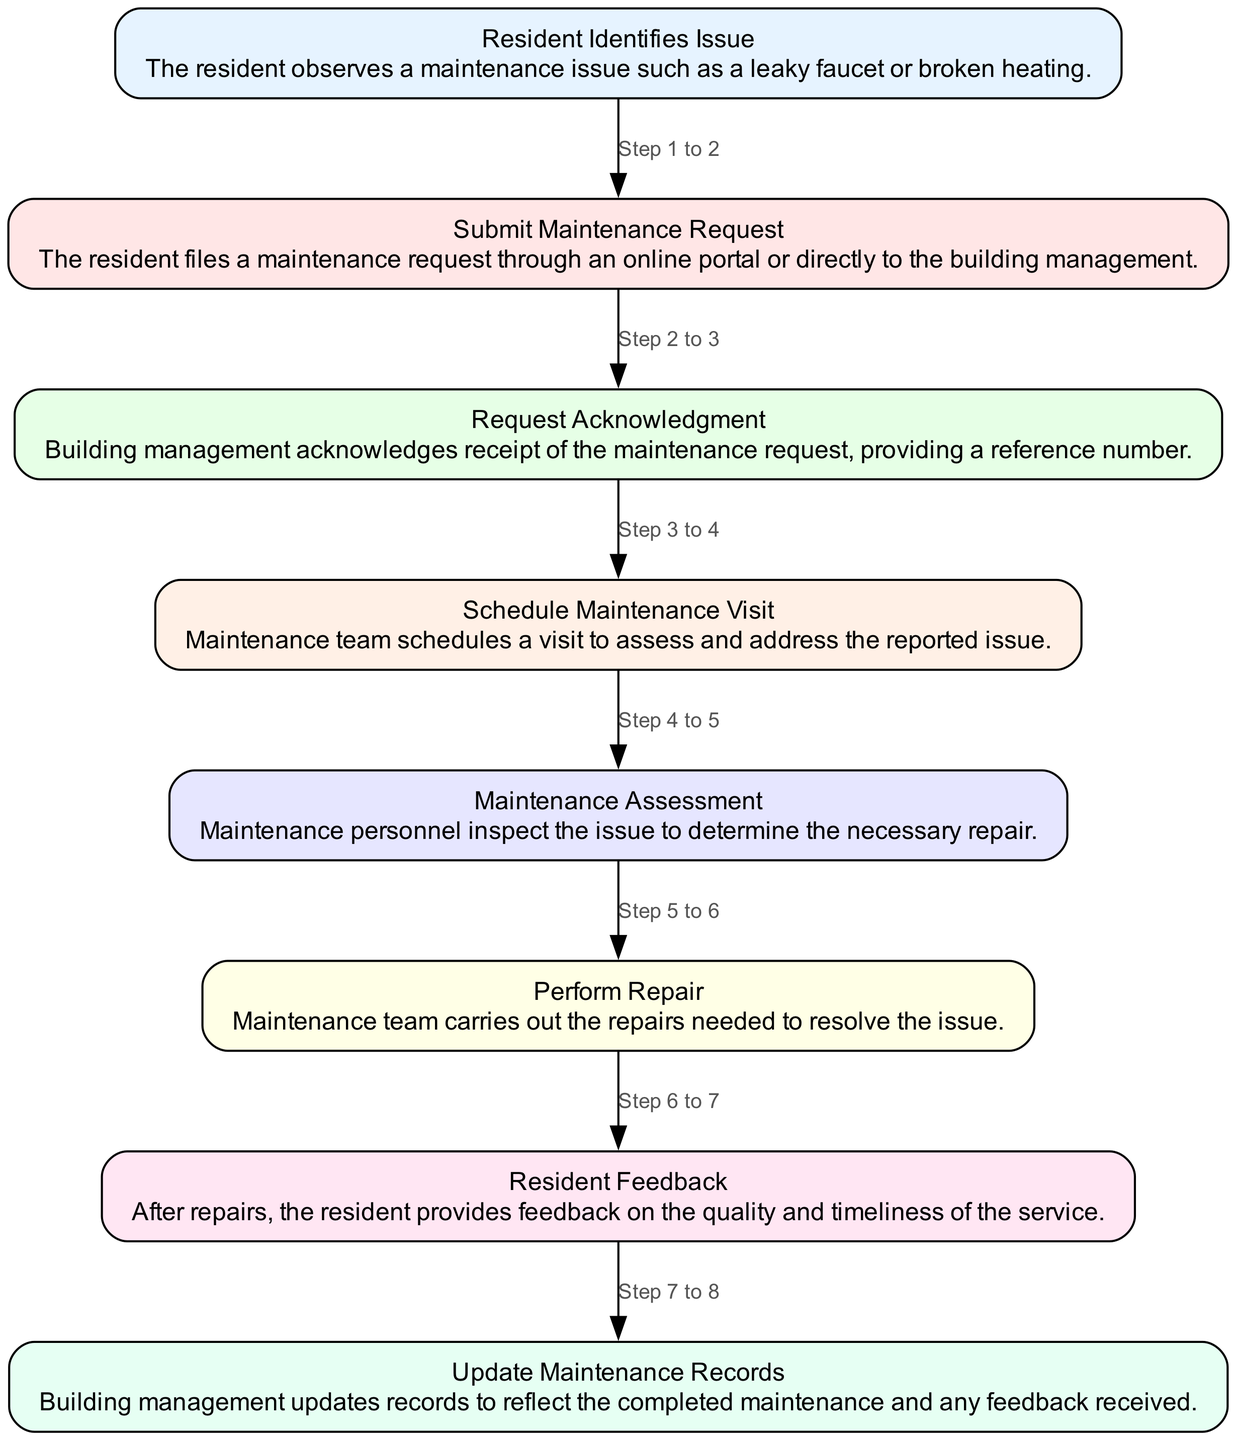What is the first step in the maintenance request process? The first step in the diagram starts with the "Resident Identifies Issue" node, indicating that the resident must recognize a maintenance problem before any action is taken.
Answer: Resident Identifies Issue How many total nodes are there in the flow chart? The flow chart contains eight nodes, each graphically represented by a distinct box marking a particular part of the maintenance process from identifying an issue to updating maintenance records.
Answer: 8 Which step follows "Request Acknowledgment"? After "Request Acknowledgment" (Step 3), the next logical step in the flow is "Schedule Maintenance Visit" (Step 4), making it a direct continuation of the process.
Answer: Schedule Maintenance Visit What action occurs after the "Perform Repair" step? Post the "Perform Repair" step (Step 6), the resident is expected to provide feedback about the maintenance experience in the "Resident Feedback" step (Step 7), ensuring resident involvement and satisfaction assessment.
Answer: Resident Feedback What is the last step in the flow chart? The final step in the process is "Update Maintenance Records," which signifies the completion of the maintenance cycle by documenting the service performed and any resident feedback received.
Answer: Update Maintenance Records How many steps are involved in obtaining resident feedback? It takes one step to obtain resident feedback, occurring after the maintenance repair has been completed, showcasing the process's emphasis on assessing the quality of the service provided.
Answer: 1 What is the relationship between "Submit Maintenance Request" and "Request Acknowledgment"? The relationship between these two steps is sequential; "Submit Maintenance Request" (Step 2) is immediately followed by "Request Acknowledgment" (Step 3), indicating that acknowledgment happens directly after a request is made.
Answer: Sequential If a resident has an issue, what is the subsequent action they must take? Upon identifying an issue, the resident's next action is to "Submit Maintenance Request," which initiates the formal process of getting assistance for their maintenance concern.
Answer: Submit Maintenance Request 